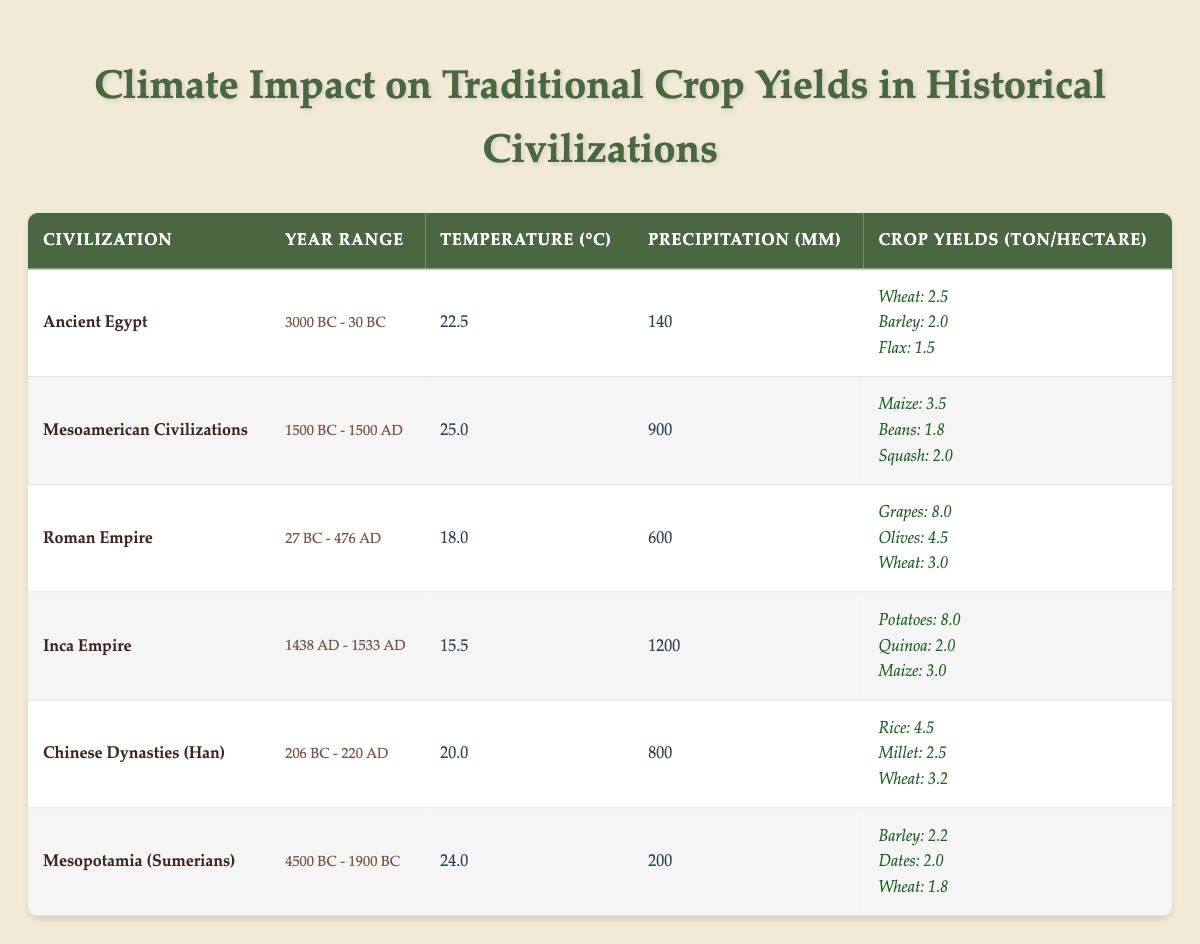What civilization had the highest crop yield for grapes? The table lists the crop yields for various civilizations. The Roman Empire's crop yield for grapes is 8.0 tons per hectare, which is the highest yield for any crop in the table.
Answer: Roman Empire Which civilization experienced the lowest precipitation? From the table, Ancient Egypt had the lowest precipitation value at 140 mm compared to all other civilizations, making it the one with the least rainfall.
Answer: Ancient Egypt What is the average crop yield for wheat across all civilizations listed? To find the average crop yield for wheat, sum the wheat yields: 2.5 (Ancient Egypt) + 3.0 (Roman Empire) + 3.2 (Chinese Dynasties) + 1.8 (Mesopotamia) = 10.5 tons. There are 4 data points, so the average is 10.5 / 4 = 2.625 tons per hectare.
Answer: 2.625 Did the Inca Empire have a higher temperature than the Roman Empire? Comparing the temperatures in the table, the Inca Empire has a temperature of 15.5°C, while the Roman Empire has a temperature of 18.0°C. Since 15.5 is less than 18.0, the statement is false.
Answer: No Which civilization had the highest combination of temperature and precipitation? The highest temperature is 25.0°C from Mesoamerican Civilizations, and the highest precipitation is 1200 mm from the Inca Empire. To get the highest combination, we add: Mesoamerican Civilizations' temperature to precipitation (25.0 + 900 = 925) is greater than the Inca Empire's (15.5 + 1200 = 1215), thus concluding that the Inca Empire has the highest total.
Answer: Inca Empire 